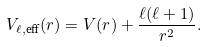Convert formula to latex. <formula><loc_0><loc_0><loc_500><loc_500>V _ { \ell , \text {eff} } ( r ) = V ( r ) + \frac { \ell ( \ell + 1 ) } { r ^ { 2 } } .</formula> 